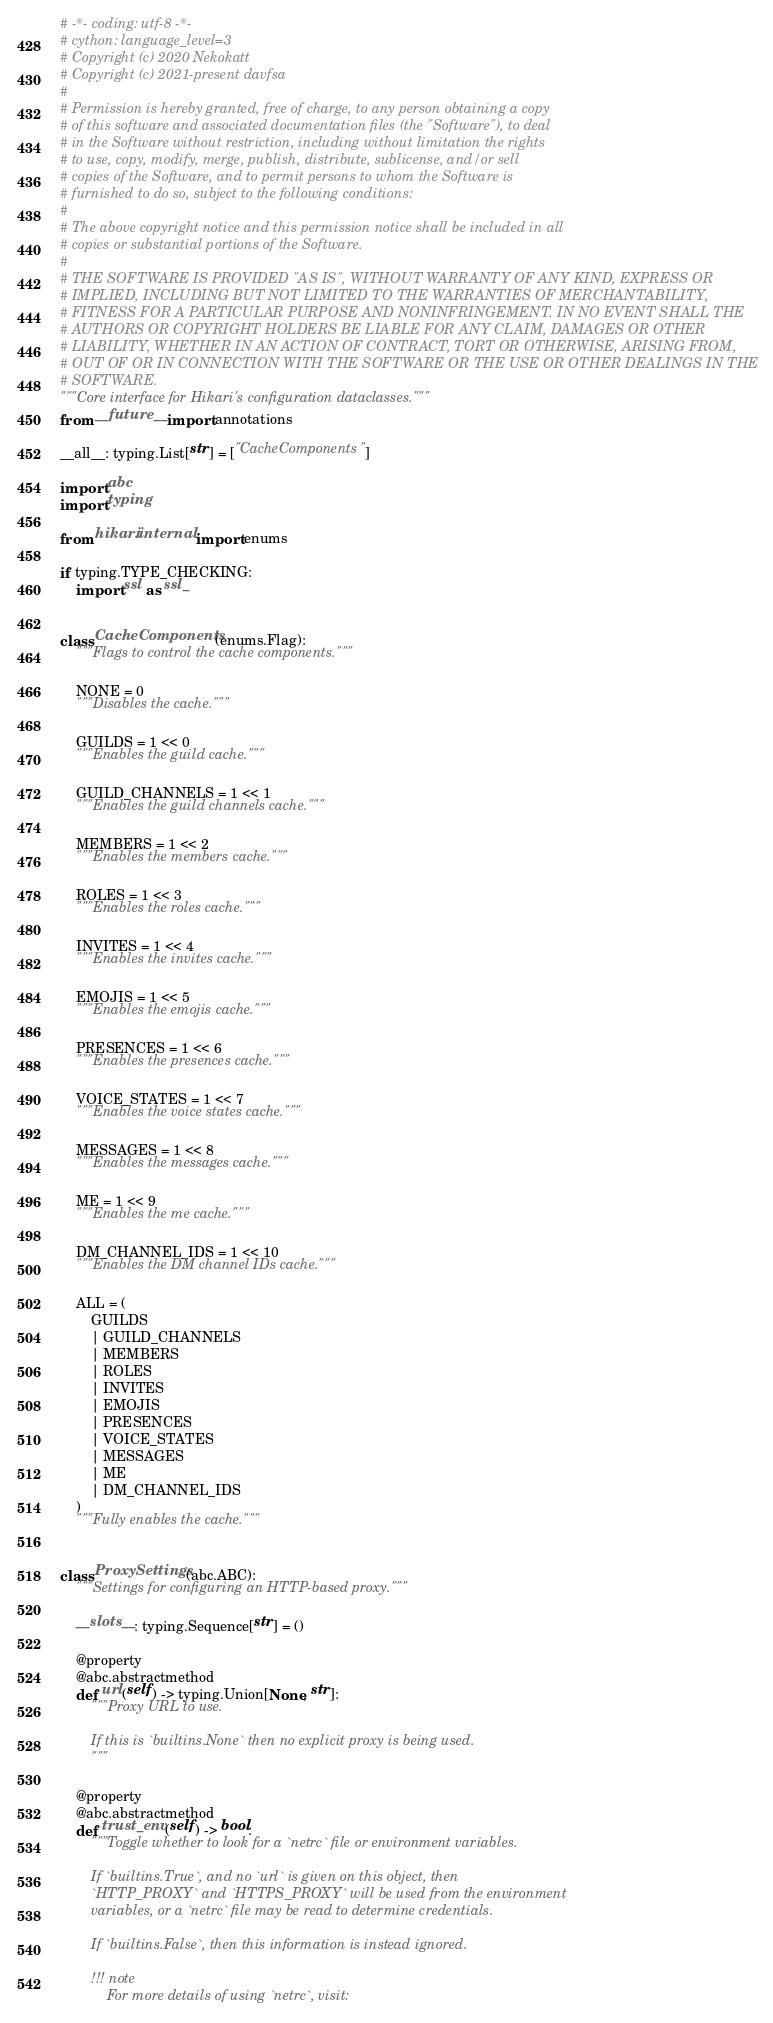<code> <loc_0><loc_0><loc_500><loc_500><_Python_># -*- coding: utf-8 -*-
# cython: language_level=3
# Copyright (c) 2020 Nekokatt
# Copyright (c) 2021-present davfsa
#
# Permission is hereby granted, free of charge, to any person obtaining a copy
# of this software and associated documentation files (the "Software"), to deal
# in the Software without restriction, including without limitation the rights
# to use, copy, modify, merge, publish, distribute, sublicense, and/or sell
# copies of the Software, and to permit persons to whom the Software is
# furnished to do so, subject to the following conditions:
#
# The above copyright notice and this permission notice shall be included in all
# copies or substantial portions of the Software.
#
# THE SOFTWARE IS PROVIDED "AS IS", WITHOUT WARRANTY OF ANY KIND, EXPRESS OR
# IMPLIED, INCLUDING BUT NOT LIMITED TO THE WARRANTIES OF MERCHANTABILITY,
# FITNESS FOR A PARTICULAR PURPOSE AND NONINFRINGEMENT. IN NO EVENT SHALL THE
# AUTHORS OR COPYRIGHT HOLDERS BE LIABLE FOR ANY CLAIM, DAMAGES OR OTHER
# LIABILITY, WHETHER IN AN ACTION OF CONTRACT, TORT OR OTHERWISE, ARISING FROM,
# OUT OF OR IN CONNECTION WITH THE SOFTWARE OR THE USE OR OTHER DEALINGS IN THE
# SOFTWARE.
"""Core interface for Hikari's configuration dataclasses."""
from __future__ import annotations

__all__: typing.List[str] = ["CacheComponents"]

import abc
import typing

from hikari.internal import enums

if typing.TYPE_CHECKING:
    import ssl as ssl_


class CacheComponents(enums.Flag):
    """Flags to control the cache components."""

    NONE = 0
    """Disables the cache."""

    GUILDS = 1 << 0
    """Enables the guild cache."""

    GUILD_CHANNELS = 1 << 1
    """Enables the guild channels cache."""

    MEMBERS = 1 << 2
    """Enables the members cache."""

    ROLES = 1 << 3
    """Enables the roles cache."""

    INVITES = 1 << 4
    """Enables the invites cache."""

    EMOJIS = 1 << 5
    """Enables the emojis cache."""

    PRESENCES = 1 << 6
    """Enables the presences cache."""

    VOICE_STATES = 1 << 7
    """Enables the voice states cache."""

    MESSAGES = 1 << 8
    """Enables the messages cache."""

    ME = 1 << 9
    """Enables the me cache."""

    DM_CHANNEL_IDS = 1 << 10
    """Enables the DM channel IDs cache."""

    ALL = (
        GUILDS
        | GUILD_CHANNELS
        | MEMBERS
        | ROLES
        | INVITES
        | EMOJIS
        | PRESENCES
        | VOICE_STATES
        | MESSAGES
        | ME
        | DM_CHANNEL_IDS
    )
    """Fully enables the cache."""


class ProxySettings(abc.ABC):
    """Settings for configuring an HTTP-based proxy."""

    __slots__: typing.Sequence[str] = ()

    @property
    @abc.abstractmethod
    def url(self) -> typing.Union[None, str]:
        """Proxy URL to use.

        If this is `builtins.None` then no explicit proxy is being used.
        """

    @property
    @abc.abstractmethod
    def trust_env(self) -> bool:
        """Toggle whether to look for a `netrc` file or environment variables.

        If `builtins.True`, and no `url` is given on this object, then
        `HTTP_PROXY` and `HTTPS_PROXY` will be used from the environment
        variables, or a `netrc` file may be read to determine credentials.

        If `builtins.False`, then this information is instead ignored.

        !!! note
            For more details of using `netrc`, visit:</code> 